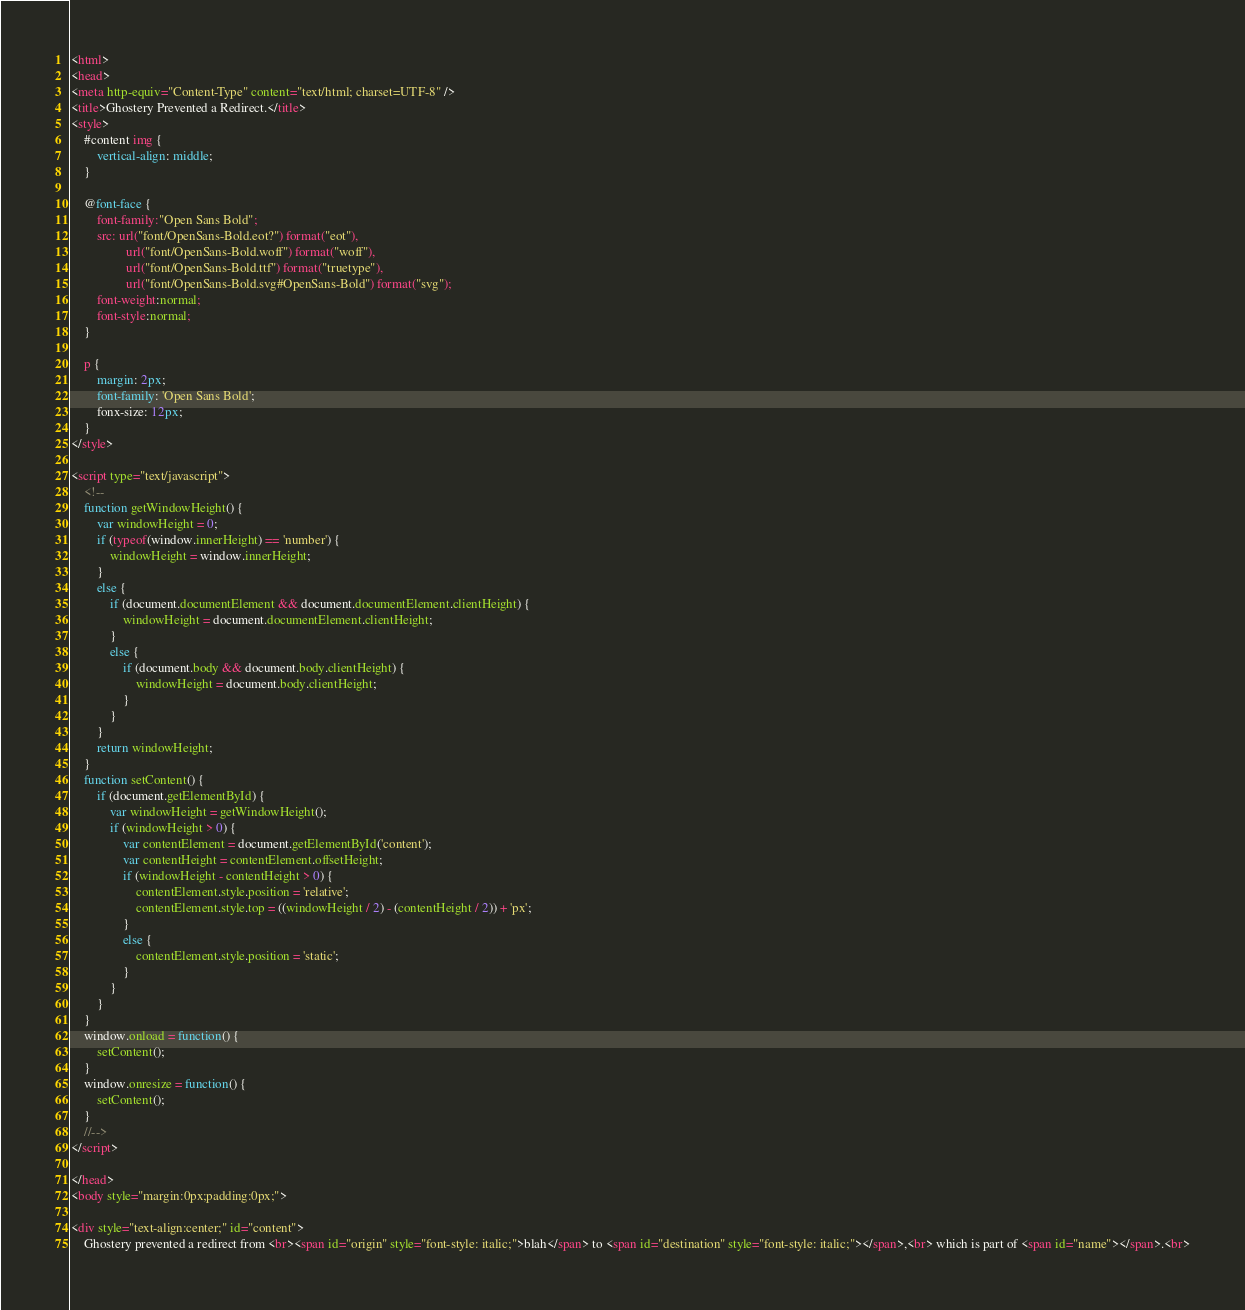Convert code to text. <code><loc_0><loc_0><loc_500><loc_500><_HTML_><html>
<head>
<meta http-equiv="Content-Type" content="text/html; charset=UTF-8" />
<title>Ghostery Prevented a Redirect.</title>
<style>
	#content img {
		vertical-align: middle;
	}

	@font-face {
		font-family:"Open Sans Bold";
		src: url("font/OpenSans-Bold.eot?") format("eot"), 
				 url("font/OpenSans-Bold.woff") format("woff"),
				 url("font/OpenSans-Bold.ttf") format("truetype"),
				 url("font/OpenSans-Bold.svg#OpenSans-Bold") format("svg");
		font-weight:normal;
		font-style:normal;
	}

	p {
		margin: 2px;
		font-family: 'Open Sans Bold';
		fonx-size: 12px;
	}
</style>

<script type="text/javascript">
	<!--
	function getWindowHeight() {
		var windowHeight = 0;
		if (typeof(window.innerHeight) == 'number') {
			windowHeight = window.innerHeight;
		}
		else {
			if (document.documentElement && document.documentElement.clientHeight) {
				windowHeight = document.documentElement.clientHeight;
			}
			else {
				if (document.body && document.body.clientHeight) {
					windowHeight = document.body.clientHeight;
				}
			}
		}
		return windowHeight;
	}
	function setContent() {
		if (document.getElementById) {
			var windowHeight = getWindowHeight();
			if (windowHeight > 0) {
				var contentElement = document.getElementById('content');
				var contentHeight = contentElement.offsetHeight;
				if (windowHeight - contentHeight > 0) {
					contentElement.style.position = 'relative';
					contentElement.style.top = ((windowHeight / 2) - (contentHeight / 2)) + 'px';
				}
				else {
					contentElement.style.position = 'static';
				}
			}
		}
	}
	window.onload = function() {
		setContent();
	}
	window.onresize = function() {
		setContent();
	}
	//-->
</script>

</head>
<body style="margin:0px;padding:0px;">

<div style="text-align:center;" id="content">
	Ghostery prevented a redirect from <br><span id="origin" style="font-style: italic;">blah</span> to <span id="destination" style="font-style: italic;"></span>,<br> which is part of <span id="name"></span>.<br></code> 